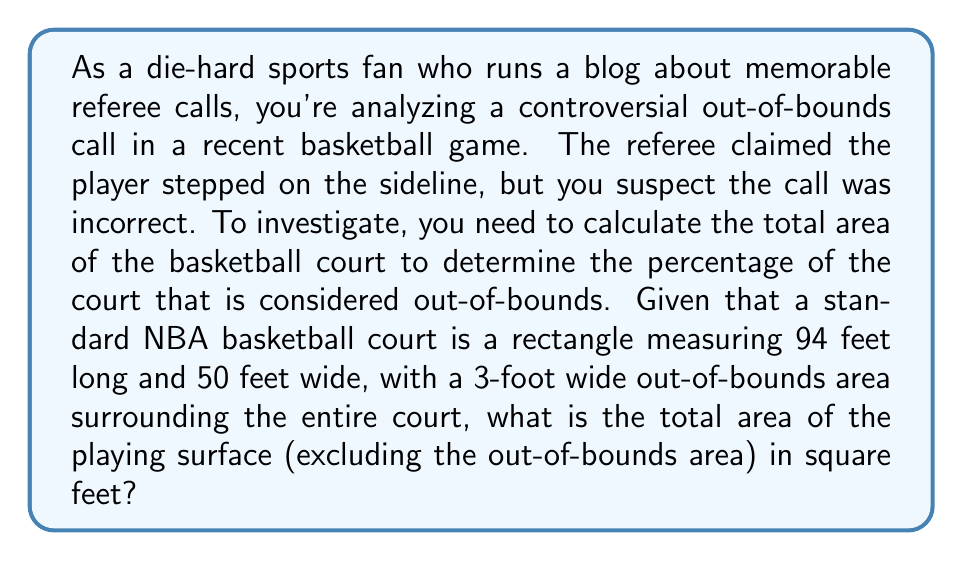Provide a solution to this math problem. To solve this problem, we need to follow these steps:

1. Calculate the total area of the court, including the out-of-bounds area:
   Let's call the length $L$ and the width $W$.
   $$L = 94 + 2(3) = 100\text{ feet}$$
   $$W = 50 + 2(3) = 56\text{ feet}$$
   Total area = $L \times W = 100 \times 56 = 5600\text{ sq ft}$

2. Calculate the area of the playing surface:
   Playing surface length = $94\text{ feet}$
   Playing surface width = $50\text{ feet}$
   Playing surface area = $94 \times 50 = 4700\text{ sq ft}$

3. The difference between the total area and the playing surface area is the out-of-bounds area:
   Out-of-bounds area = $5600 - 4700 = 900\text{ sq ft}$

Therefore, the area of the playing surface is 4700 square feet.

[asy]
unitsize(2mm);
draw((0,0)--(100,0)--(100,56)--(0,56)--cycle);
draw((3,3)--(97,3)--(97,53)--(3,53)--cycle);
label("100 ft", (50,-2), S);
label("56 ft", (-2,28), W, rotate(90));
label("94 ft", (50,5), N);
label("50 ft", (5,28), E, rotate(90));
[/asy]
Answer: The area of the playing surface is 4700 square feet. 